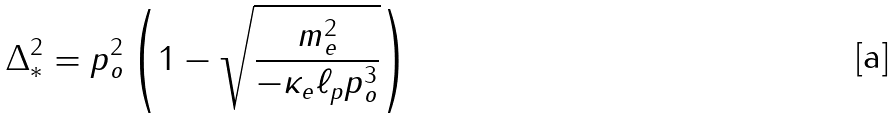Convert formula to latex. <formula><loc_0><loc_0><loc_500><loc_500>\Delta _ { * } ^ { 2 } = p _ { o } ^ { 2 } \left ( 1 - \sqrt { \frac { m _ { e } ^ { 2 } } { - \kappa _ { e } \ell _ { p } p _ { o } ^ { 3 } } } \right )</formula> 